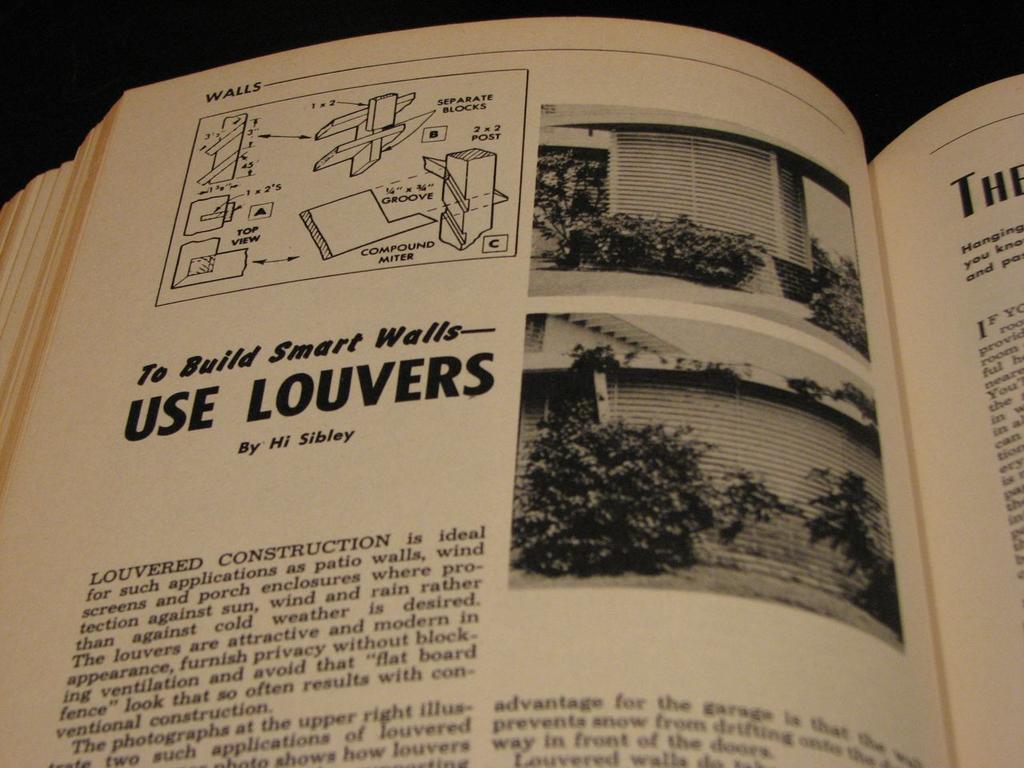What is the top most saying on the left page?
Your answer should be very brief. Walls. Who is the author?
Provide a short and direct response. Hi sibley. 